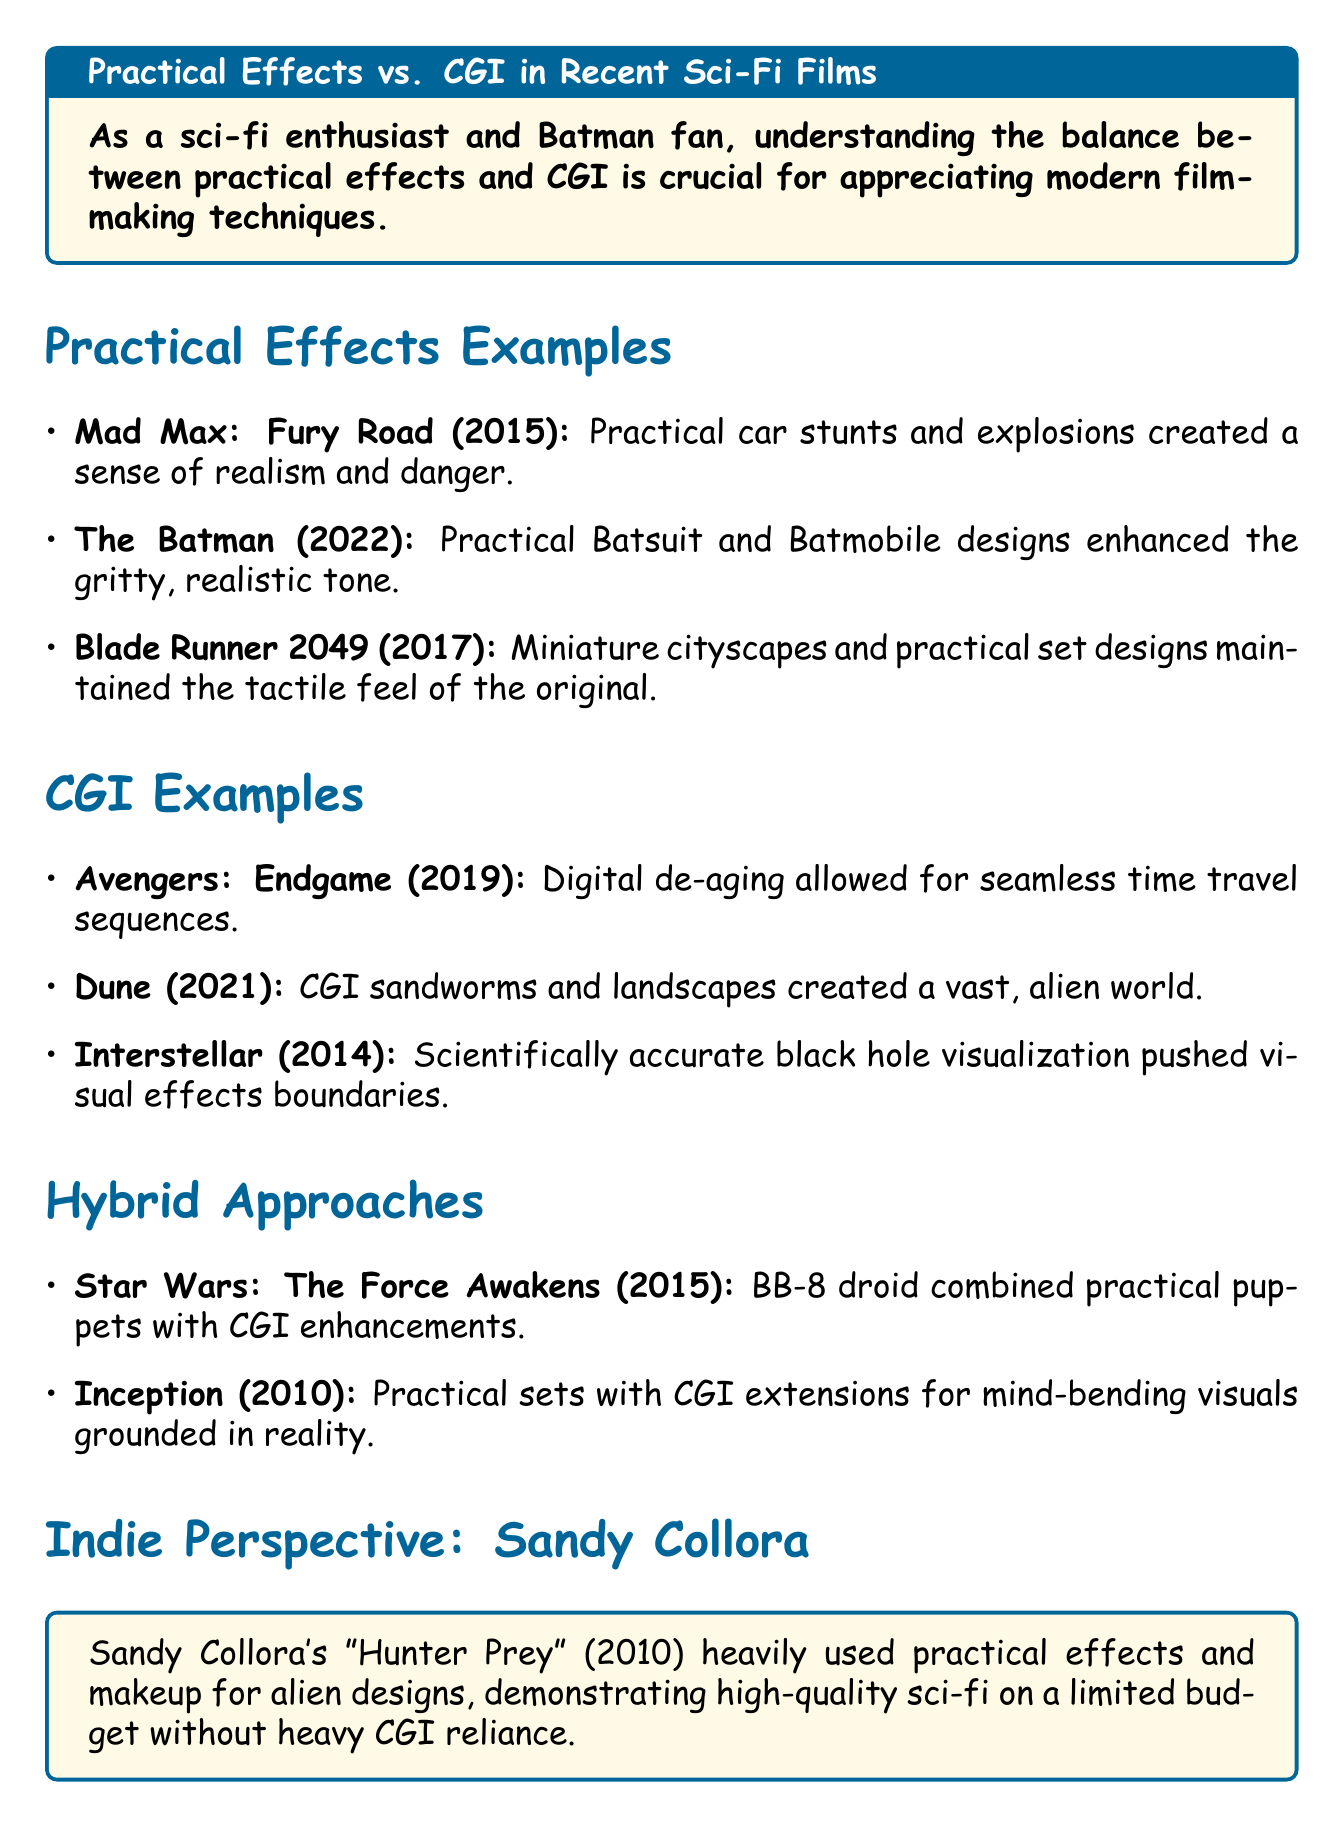What movie features practical car stunts and explosions? The document lists "Mad Max: Fury Road" as featuring practical car stunts and explosions.
Answer: Mad Max: Fury Road In what year was "The Batman" released? The memo states that "The Batman" was released in 2022.
Answer: 2022 What notable CGI effect was used in "Avengers: Endgame"? The document mentions that "Avengers: Endgame" utilized digital de-aging of characters.
Answer: Digital de-aging Which movie used heavy practical effects and makeup for alien designs? The document specifically mentions Sandy Collora's "Hunter Prey" for its use of practical effects and makeup.
Answer: Hunter Prey What is the significance of LED wall technology in future filmmaking? The document explains that LED wall technology could blur the line between practical and digital effects, revolutionizing sci-fi filmmaking.
Answer: Revolutionizing sci-fi filmmaking What practical effect enhanced the tone of "Blade Runner 2049"? The memo discusses miniature cityscapes and practical set designs as a notable effect in "Blade Runner 2049".
Answer: Miniature cityscapes What hybrid approach was used in "Star Wars: The Force Awakens"? The document notes that "Star Wars: The Force Awakens" combined practical puppets with CGI enhancements.
Answer: Practical puppets with CGI enhancements What is a key takeaway mentioned in the conclusion? The document states that the most effective sci-fi films often blend practical effects and CGI.
Answer: Blend practical effects and CGI 